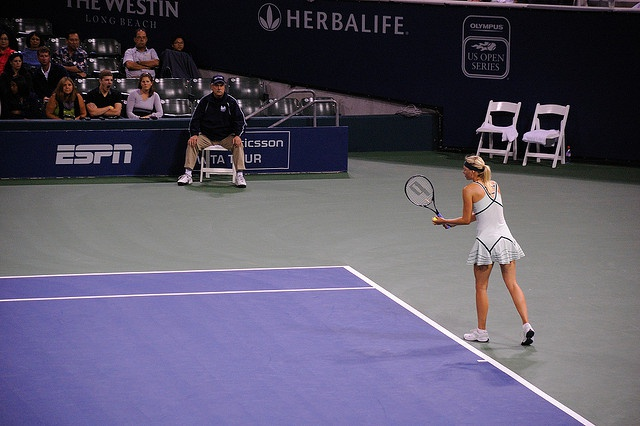Describe the objects in this image and their specific colors. I can see people in black, lightgray, darkgray, and brown tones, people in black, gray, and maroon tones, chair in black, darkgray, pink, and gray tones, chair in black, darkgray, pink, and gray tones, and chair in black, gray, and darkgray tones in this image. 